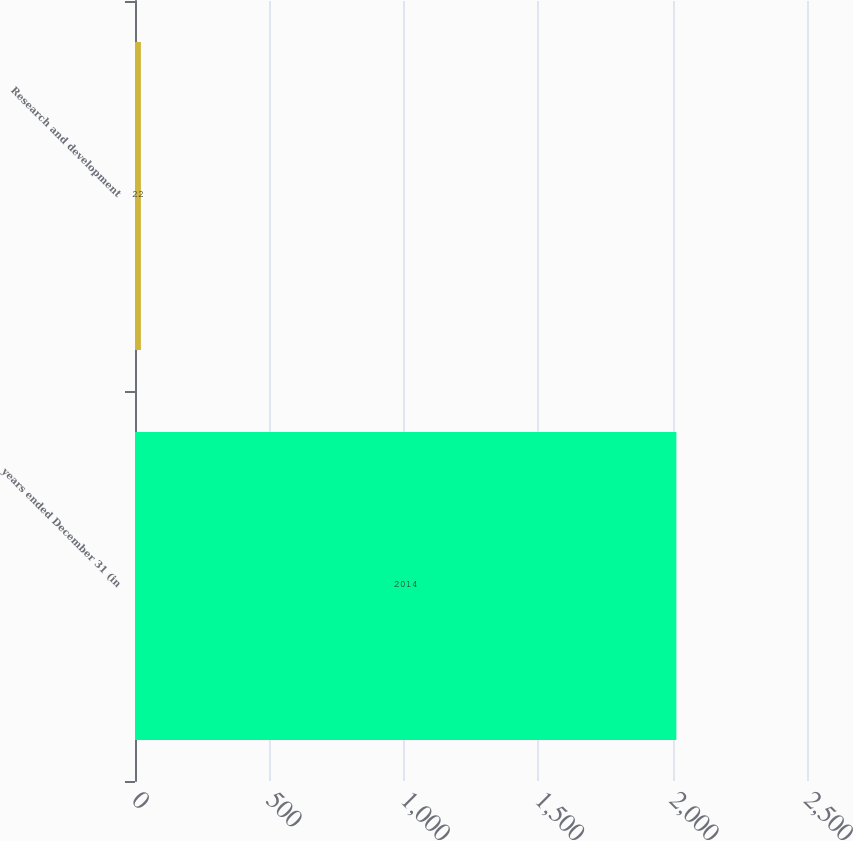Convert chart. <chart><loc_0><loc_0><loc_500><loc_500><bar_chart><fcel>years ended December 31 (in<fcel>Research and development<nl><fcel>2014<fcel>22<nl></chart> 